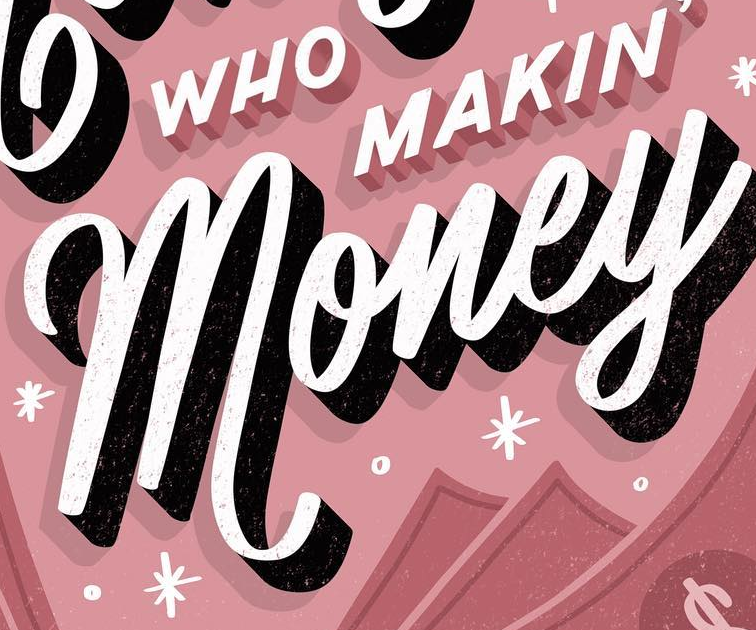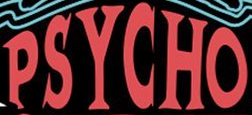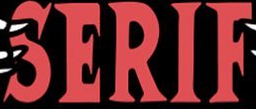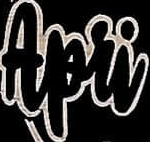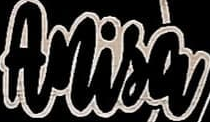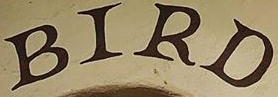What words can you see in these images in sequence, separated by a semicolon? money; PSYCHO; SERIF; Apri; Anisa; BIRD 